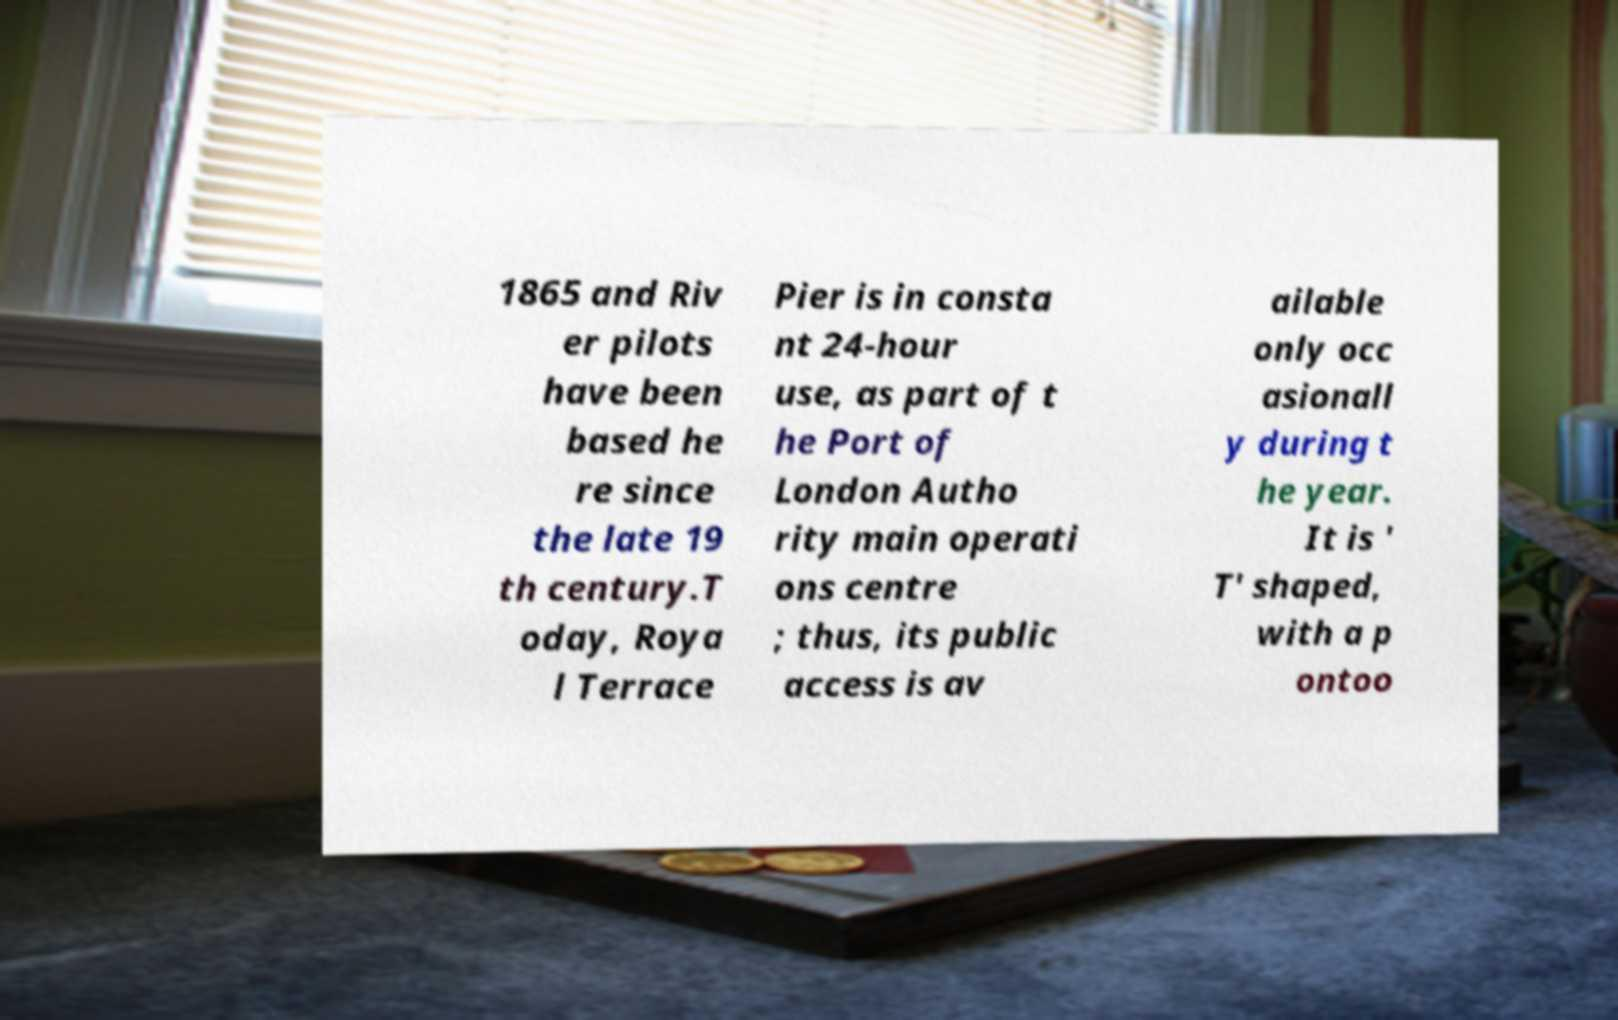There's text embedded in this image that I need extracted. Can you transcribe it verbatim? 1865 and Riv er pilots have been based he re since the late 19 th century.T oday, Roya l Terrace Pier is in consta nt 24-hour use, as part of t he Port of London Autho rity main operati ons centre ; thus, its public access is av ailable only occ asionall y during t he year. It is ' T' shaped, with a p ontoo 